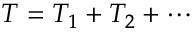<formula> <loc_0><loc_0><loc_500><loc_500>\begin{array} { r } { T = T _ { 1 } + T _ { 2 } + \cdots } \end{array}</formula> 